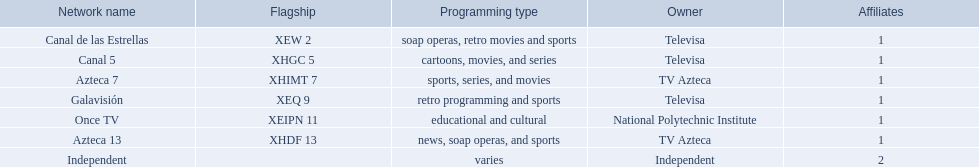Can you parse all the data within this table? {'header': ['Network name', 'Flagship', 'Programming type', 'Owner', 'Affiliates'], 'rows': [['Canal de las Estrellas', 'XEW 2', 'soap operas, retro movies and sports', 'Televisa', '1'], ['Canal 5', 'XHGC 5', 'cartoons, movies, and series', 'Televisa', '1'], ['Azteca 7', 'XHIMT 7', 'sports, series, and movies', 'TV Azteca', '1'], ['Galavisión', 'XEQ 9', 'retro programming and sports', 'Televisa', '1'], ['Once TV', 'XEIPN 11', 'educational and cultural', 'National Polytechnic Institute', '1'], ['Azteca 13', 'XHDF 13', 'news, soap operas, and sports', 'TV Azteca', '1'], ['Independent', '', 'varies', 'Independent', '2']]} Which channel broadcasts animated series? Canal 5. Which channel airs soap operas? Canal de las Estrellas. Which channel features sports programming? Azteca 7. 